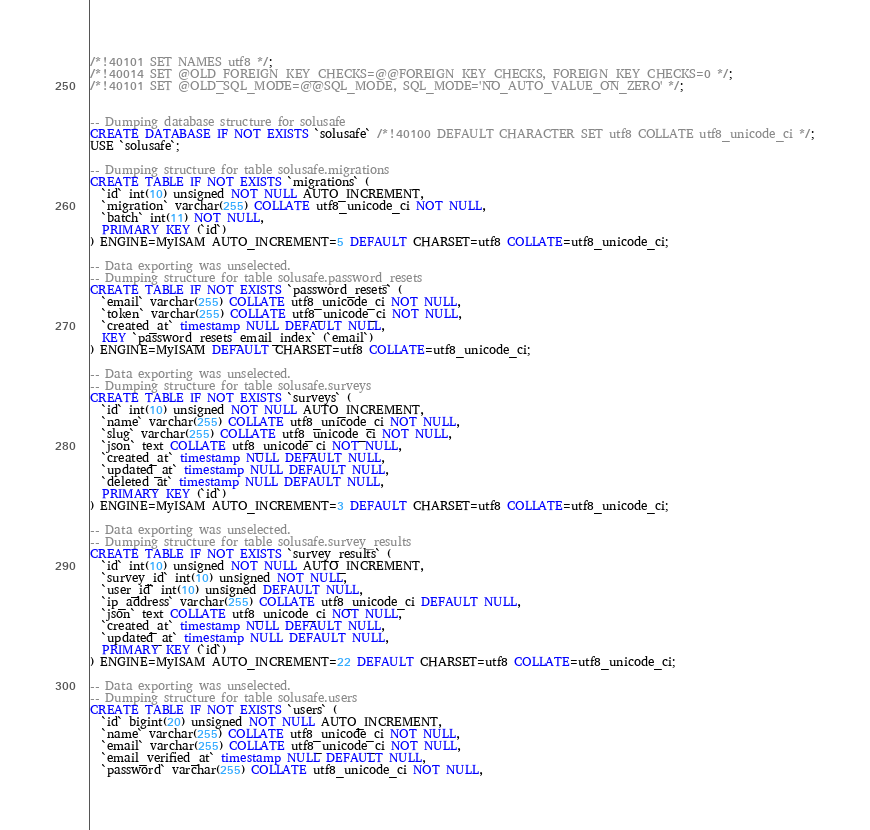Convert code to text. <code><loc_0><loc_0><loc_500><loc_500><_SQL_>/*!40101 SET NAMES utf8 */;
/*!40014 SET @OLD_FOREIGN_KEY_CHECKS=@@FOREIGN_KEY_CHECKS, FOREIGN_KEY_CHECKS=0 */;
/*!40101 SET @OLD_SQL_MODE=@@SQL_MODE, SQL_MODE='NO_AUTO_VALUE_ON_ZERO' */;


-- Dumping database structure for solusafe
CREATE DATABASE IF NOT EXISTS `solusafe` /*!40100 DEFAULT CHARACTER SET utf8 COLLATE utf8_unicode_ci */;
USE `solusafe`;

-- Dumping structure for table solusafe.migrations
CREATE TABLE IF NOT EXISTS `migrations` (
  `id` int(10) unsigned NOT NULL AUTO_INCREMENT,
  `migration` varchar(255) COLLATE utf8_unicode_ci NOT NULL,
  `batch` int(11) NOT NULL,
  PRIMARY KEY (`id`)
) ENGINE=MyISAM AUTO_INCREMENT=5 DEFAULT CHARSET=utf8 COLLATE=utf8_unicode_ci;

-- Data exporting was unselected.
-- Dumping structure for table solusafe.password_resets
CREATE TABLE IF NOT EXISTS `password_resets` (
  `email` varchar(255) COLLATE utf8_unicode_ci NOT NULL,
  `token` varchar(255) COLLATE utf8_unicode_ci NOT NULL,
  `created_at` timestamp NULL DEFAULT NULL,
  KEY `password_resets_email_index` (`email`)
) ENGINE=MyISAM DEFAULT CHARSET=utf8 COLLATE=utf8_unicode_ci;

-- Data exporting was unselected.
-- Dumping structure for table solusafe.surveys
CREATE TABLE IF NOT EXISTS `surveys` (
  `id` int(10) unsigned NOT NULL AUTO_INCREMENT,
  `name` varchar(255) COLLATE utf8_unicode_ci NOT NULL,
  `slug` varchar(255) COLLATE utf8_unicode_ci NOT NULL,
  `json` text COLLATE utf8_unicode_ci NOT NULL,
  `created_at` timestamp NULL DEFAULT NULL,
  `updated_at` timestamp NULL DEFAULT NULL,
  `deleted_at` timestamp NULL DEFAULT NULL,
  PRIMARY KEY (`id`)
) ENGINE=MyISAM AUTO_INCREMENT=3 DEFAULT CHARSET=utf8 COLLATE=utf8_unicode_ci;

-- Data exporting was unselected.
-- Dumping structure for table solusafe.survey_results
CREATE TABLE IF NOT EXISTS `survey_results` (
  `id` int(10) unsigned NOT NULL AUTO_INCREMENT,
  `survey_id` int(10) unsigned NOT NULL,
  `user_id` int(10) unsigned DEFAULT NULL,
  `ip_address` varchar(255) COLLATE utf8_unicode_ci DEFAULT NULL,
  `json` text COLLATE utf8_unicode_ci NOT NULL,
  `created_at` timestamp NULL DEFAULT NULL,
  `updated_at` timestamp NULL DEFAULT NULL,
  PRIMARY KEY (`id`)
) ENGINE=MyISAM AUTO_INCREMENT=22 DEFAULT CHARSET=utf8 COLLATE=utf8_unicode_ci;

-- Data exporting was unselected.
-- Dumping structure for table solusafe.users
CREATE TABLE IF NOT EXISTS `users` (
  `id` bigint(20) unsigned NOT NULL AUTO_INCREMENT,
  `name` varchar(255) COLLATE utf8_unicode_ci NOT NULL,
  `email` varchar(255) COLLATE utf8_unicode_ci NOT NULL,
  `email_verified_at` timestamp NULL DEFAULT NULL,
  `password` varchar(255) COLLATE utf8_unicode_ci NOT NULL,</code> 